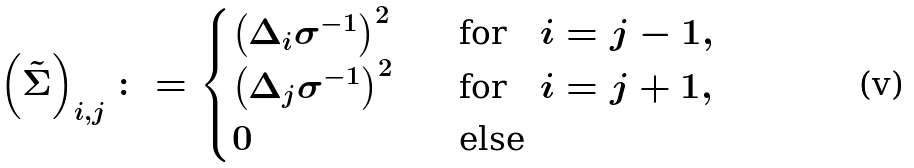Convert formula to latex. <formula><loc_0><loc_0><loc_500><loc_500>\left ( \tilde { \Sigma } \right ) _ { i , j } \colon = \begin{cases} \left ( \Delta _ { i } \sigma ^ { - 1 } \right ) ^ { 2 } \quad & \text {for} \quad i = j - 1 , \\ \left ( \Delta _ { j } \sigma ^ { - 1 } \right ) ^ { 2 } \quad & \text {for} \quad i = j + 1 , \\ 0 \quad & \text {else} \end{cases}</formula> 